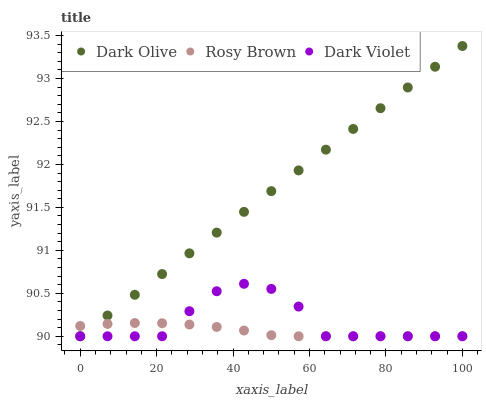Does Rosy Brown have the minimum area under the curve?
Answer yes or no. Yes. Does Dark Olive have the maximum area under the curve?
Answer yes or no. Yes. Does Dark Violet have the minimum area under the curve?
Answer yes or no. No. Does Dark Violet have the maximum area under the curve?
Answer yes or no. No. Is Dark Olive the smoothest?
Answer yes or no. Yes. Is Dark Violet the roughest?
Answer yes or no. Yes. Is Dark Violet the smoothest?
Answer yes or no. No. Is Dark Olive the roughest?
Answer yes or no. No. Does Rosy Brown have the lowest value?
Answer yes or no. Yes. Does Dark Olive have the highest value?
Answer yes or no. Yes. Does Dark Violet have the highest value?
Answer yes or no. No. Does Dark Olive intersect Dark Violet?
Answer yes or no. Yes. Is Dark Olive less than Dark Violet?
Answer yes or no. No. Is Dark Olive greater than Dark Violet?
Answer yes or no. No. 